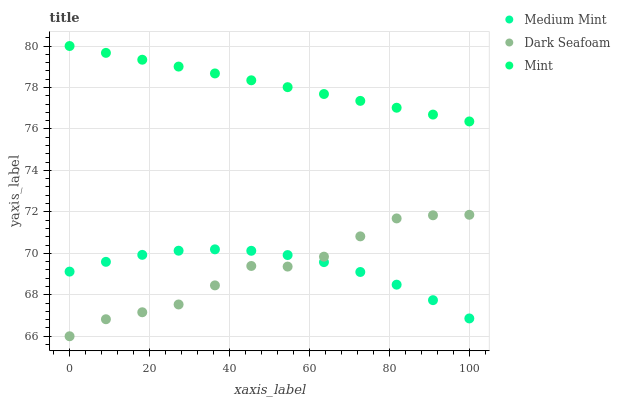Does Dark Seafoam have the minimum area under the curve?
Answer yes or no. Yes. Does Mint have the maximum area under the curve?
Answer yes or no. Yes. Does Mint have the minimum area under the curve?
Answer yes or no. No. Does Dark Seafoam have the maximum area under the curve?
Answer yes or no. No. Is Mint the smoothest?
Answer yes or no. Yes. Is Dark Seafoam the roughest?
Answer yes or no. Yes. Is Dark Seafoam the smoothest?
Answer yes or no. No. Is Mint the roughest?
Answer yes or no. No. Does Dark Seafoam have the lowest value?
Answer yes or no. Yes. Does Mint have the lowest value?
Answer yes or no. No. Does Mint have the highest value?
Answer yes or no. Yes. Does Dark Seafoam have the highest value?
Answer yes or no. No. Is Dark Seafoam less than Mint?
Answer yes or no. Yes. Is Mint greater than Dark Seafoam?
Answer yes or no. Yes. Does Dark Seafoam intersect Medium Mint?
Answer yes or no. Yes. Is Dark Seafoam less than Medium Mint?
Answer yes or no. No. Is Dark Seafoam greater than Medium Mint?
Answer yes or no. No. Does Dark Seafoam intersect Mint?
Answer yes or no. No. 